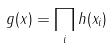<formula> <loc_0><loc_0><loc_500><loc_500>g ( x ) = \prod _ { i } h ( x _ { i } )</formula> 